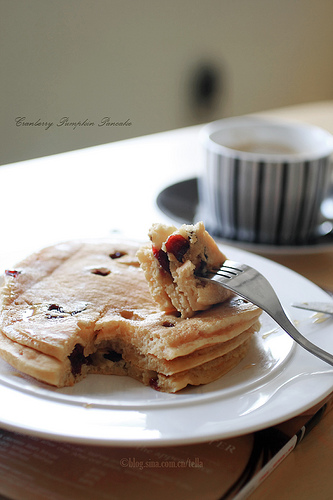<image>
Can you confirm if the fork is to the left of the cup? No. The fork is not to the left of the cup. From this viewpoint, they have a different horizontal relationship. 